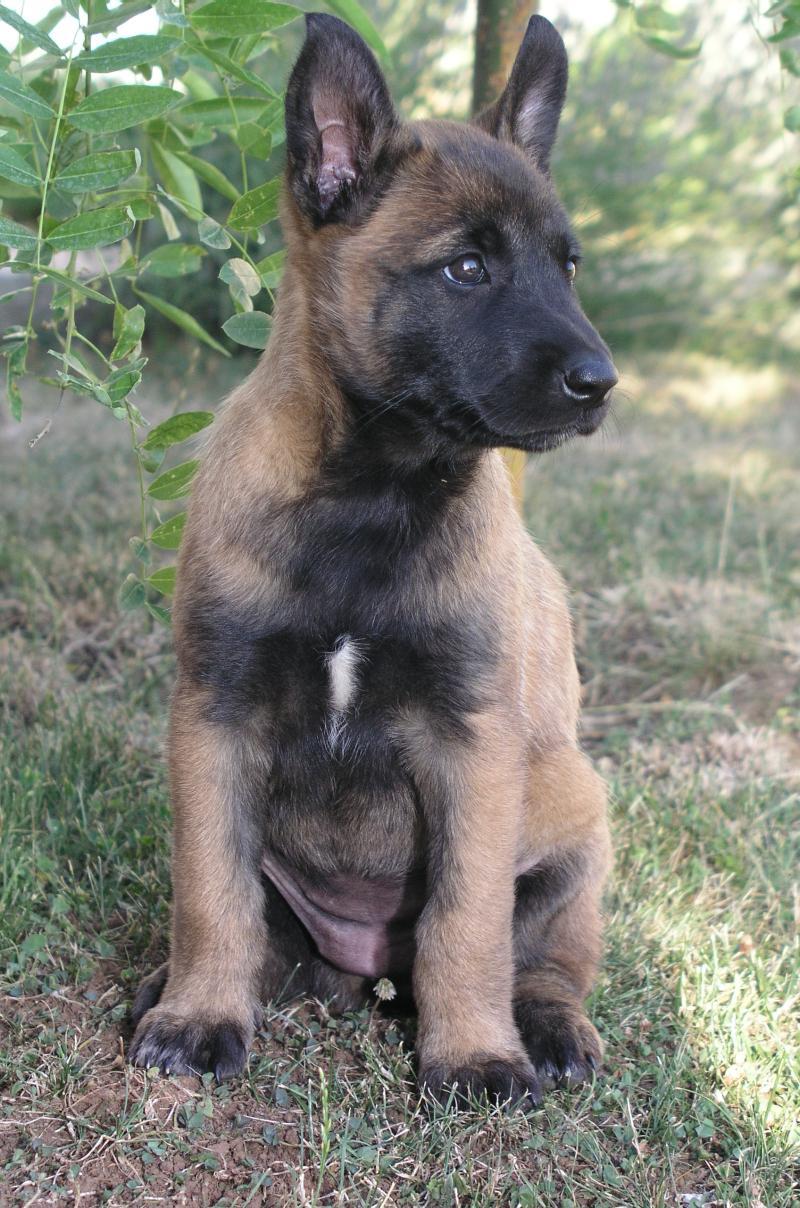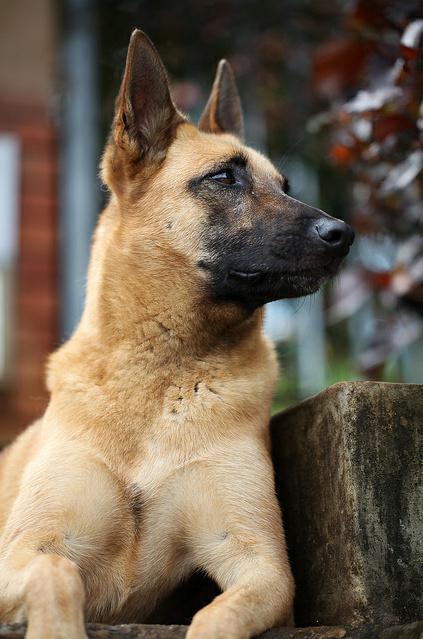The first image is the image on the left, the second image is the image on the right. Evaluate the accuracy of this statement regarding the images: "The image on the right features exactly two animals.". Is it true? Answer yes or no. No. The first image is the image on the left, the second image is the image on the right. Considering the images on both sides, is "One of the dogs has it's tongue hanging out and neither of the dogs is a puppy." valid? Answer yes or no. No. 